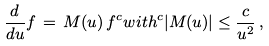<formula> <loc_0><loc_0><loc_500><loc_500>\frac { d } { d u } f \, = \, M ( u ) \, f ^ { c } { w i t h } ^ { c } | M ( u ) | \leq \frac { c } { u ^ { 2 } } \, ,</formula> 